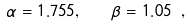<formula> <loc_0><loc_0><loc_500><loc_500>\alpha = 1 . 7 5 5 , \quad \beta = 1 . 0 5 \ ,</formula> 